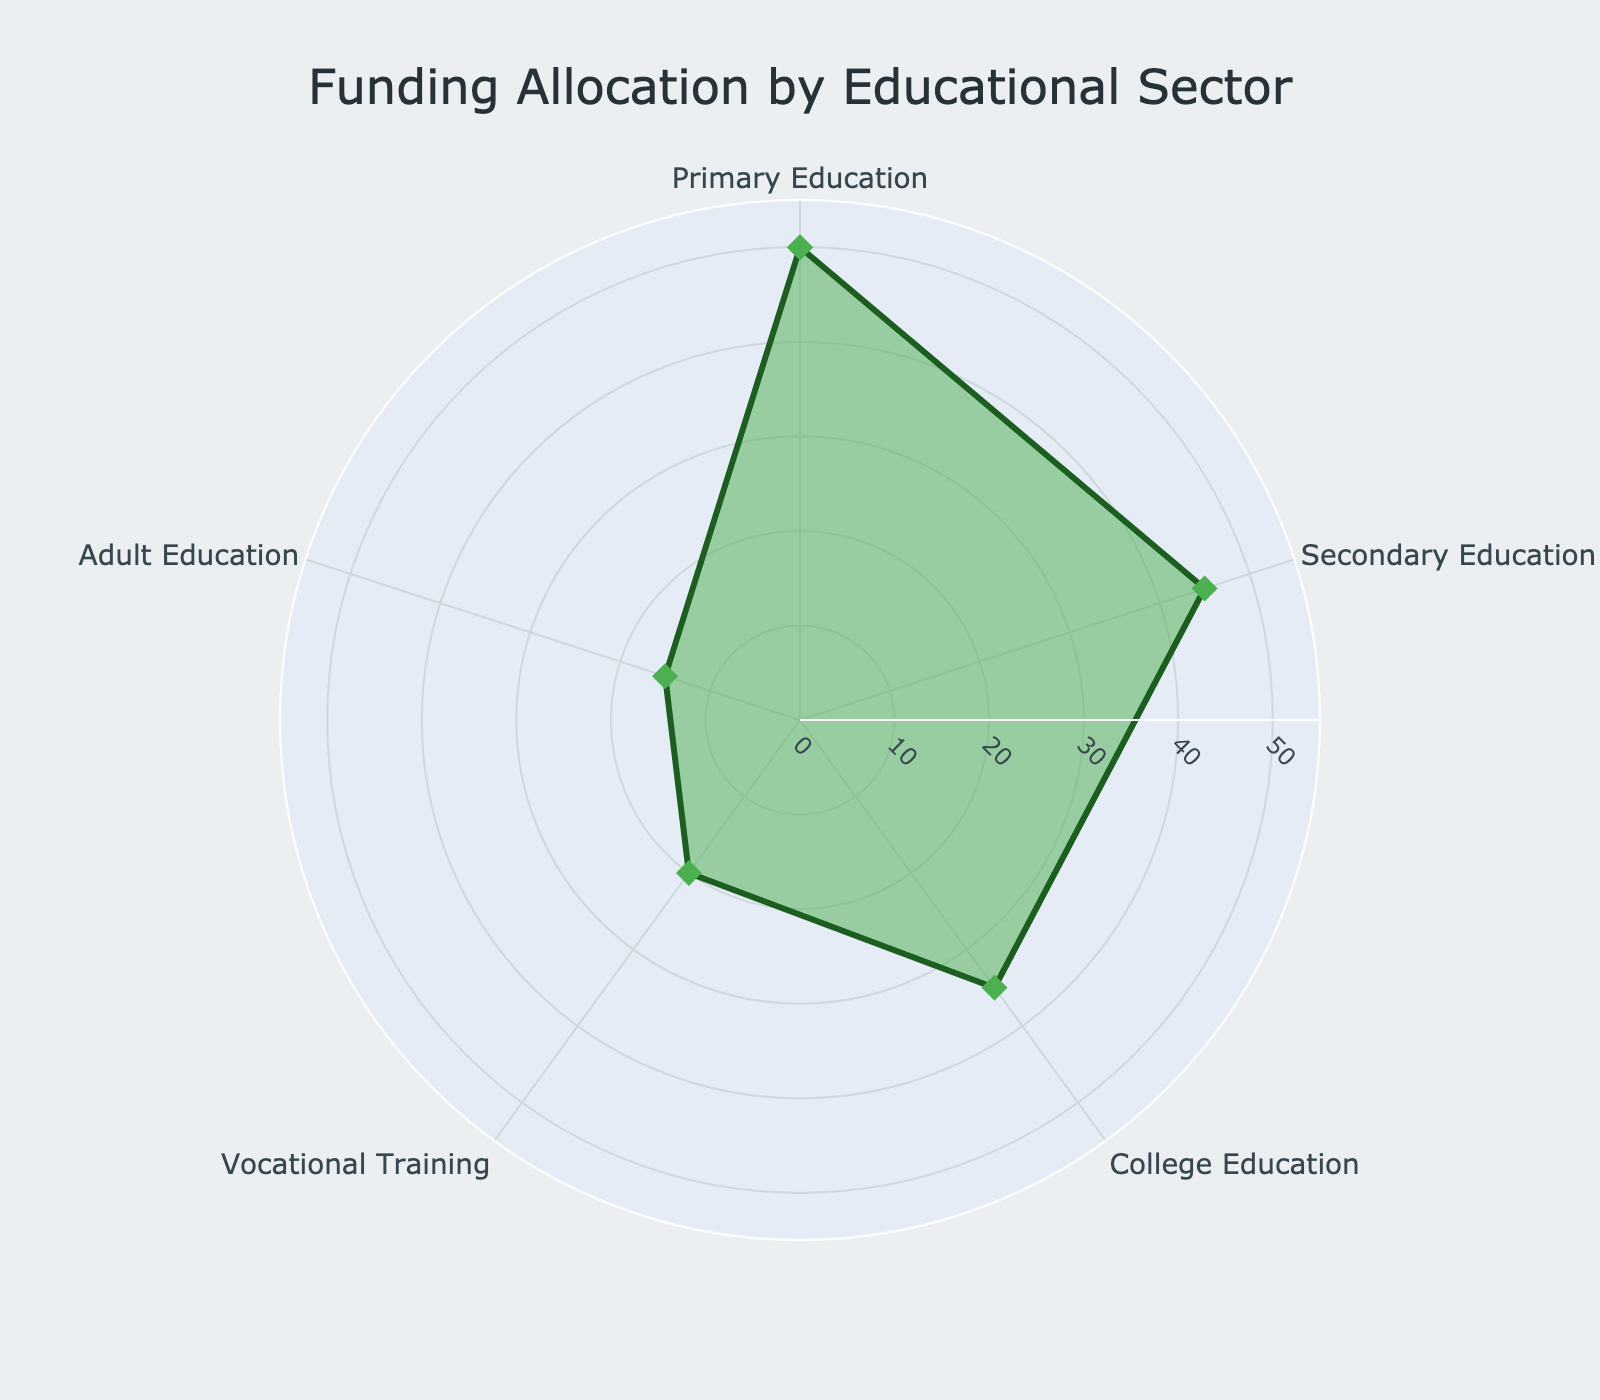What's the title of the chart? The title is the largest text at the top center of the chart, helping to interpret the overall purpose.
Answer: Funding Allocation by Educational Sector Which educational sector received the highest funding? By comparing the radial distances of each sector, the sector with the longest distance (largest value) has the highest funding.
Answer: Primary Education What is the funding difference between Primary Education and Adult Education? Subtract the funding of Adult Education from the funding of Primary Education. So, 50 - 15 = 35.
Answer: 35 million USD Which sector received more funding, Secondary Education or Vocational Training? Compare the radial distances of Secondary Education and Vocational Training. The longer distance indicates more funding.
Answer: Secondary Education What is the average funding across all educational sectors? Sum all the funding values and divide by the number of sectors. (50 + 45 + 35 + 20 + 15) / 5 = 165 / 5 = 33.
Answer: 33 million USD How much more funding does Primary Education receive compared to College Education? Subtract the funding of College Education from Primary Education. So, 50 - 35 = 15.
Answer: 15 million USD Which sector has the lowest funding, and what is its amount? The sector with the shortest radial distance has the lowest funding.
Answer: Adult Education with 15 million USD What is the total funding for Primary, Secondary, and College Education combined? Add up the funding values for the three sectors. 50 + 45 + 35 = 130.
Answer: 130 million USD Is the funding for Vocational Training higher than the average funding across all sectors? Calculate the average (already computed as 33 million USD), then check if Vocational Training's funding (20 million USD) is higher.
Answer: No How does the funding for Secondary Education compare to College Education? Compare the radial distances of Secondary Education and College Education. The longer distance indicates more funding.
Answer: Secondary Education received more than College Education 